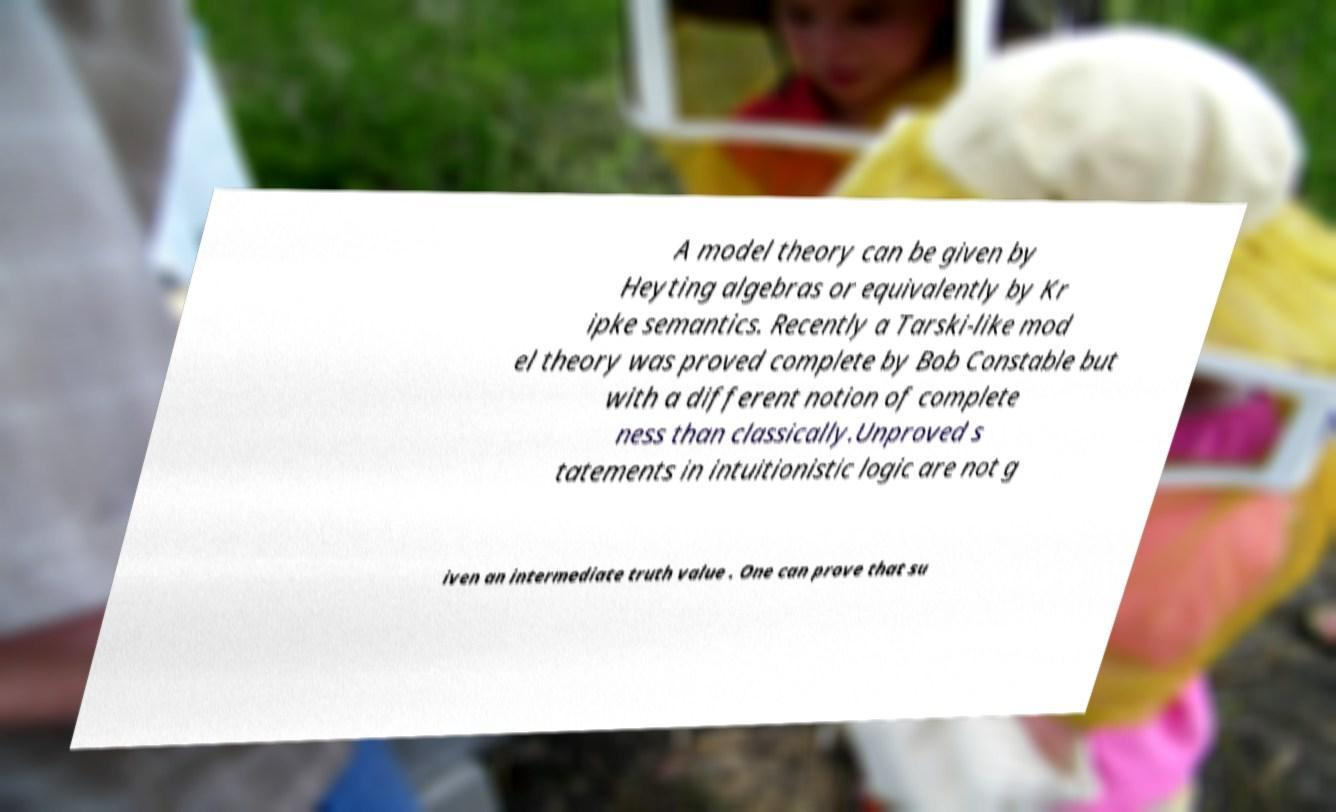Please read and relay the text visible in this image. What does it say? A model theory can be given by Heyting algebras or equivalently by Kr ipke semantics. Recently a Tarski-like mod el theory was proved complete by Bob Constable but with a different notion of complete ness than classically.Unproved s tatements in intuitionistic logic are not g iven an intermediate truth value . One can prove that su 